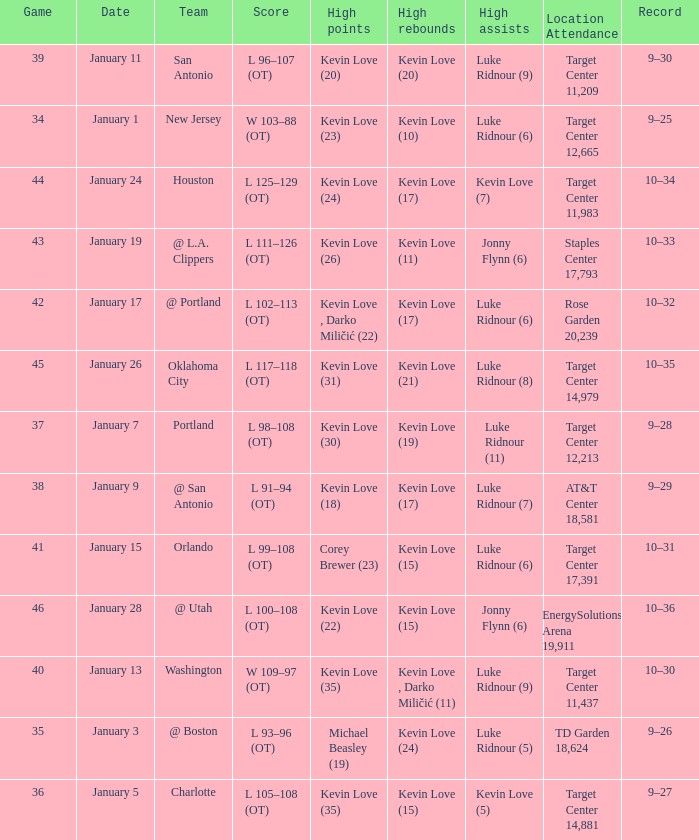In how many instances did kevin love (22) have the most points? 1.0. 